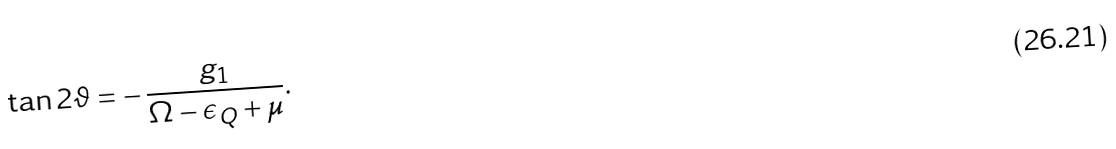<formula> <loc_0><loc_0><loc_500><loc_500>\tan 2 \vartheta = - \, \frac { g _ { 1 } } { \Omega - \epsilon _ { Q } + \mu } .</formula> 